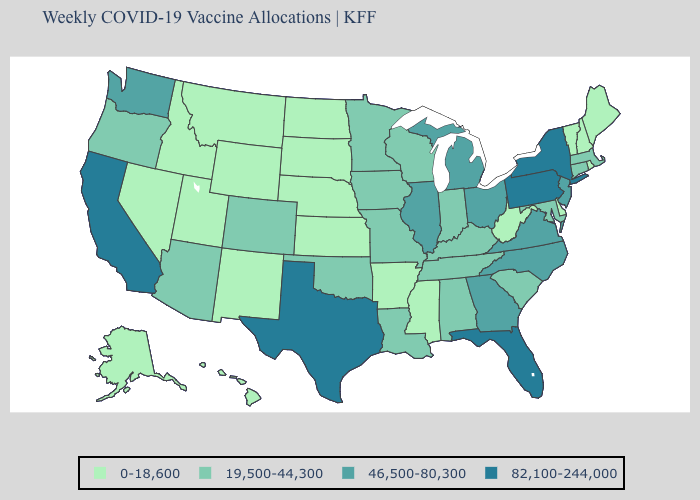Does the first symbol in the legend represent the smallest category?
Quick response, please. Yes. Name the states that have a value in the range 82,100-244,000?
Keep it brief. California, Florida, New York, Pennsylvania, Texas. Name the states that have a value in the range 0-18,600?
Concise answer only. Alaska, Arkansas, Delaware, Hawaii, Idaho, Kansas, Maine, Mississippi, Montana, Nebraska, Nevada, New Hampshire, New Mexico, North Dakota, Rhode Island, South Dakota, Utah, Vermont, West Virginia, Wyoming. Name the states that have a value in the range 82,100-244,000?
Be succinct. California, Florida, New York, Pennsylvania, Texas. What is the lowest value in the MidWest?
Be succinct. 0-18,600. Among the states that border Idaho , does Washington have the lowest value?
Quick response, please. No. How many symbols are there in the legend?
Give a very brief answer. 4. Name the states that have a value in the range 82,100-244,000?
Be succinct. California, Florida, New York, Pennsylvania, Texas. Which states have the lowest value in the West?
Be succinct. Alaska, Hawaii, Idaho, Montana, Nevada, New Mexico, Utah, Wyoming. What is the highest value in the USA?
Be succinct. 82,100-244,000. Among the states that border Delaware , which have the lowest value?
Be succinct. Maryland. Name the states that have a value in the range 0-18,600?
Short answer required. Alaska, Arkansas, Delaware, Hawaii, Idaho, Kansas, Maine, Mississippi, Montana, Nebraska, Nevada, New Hampshire, New Mexico, North Dakota, Rhode Island, South Dakota, Utah, Vermont, West Virginia, Wyoming. Among the states that border Mississippi , does Tennessee have the lowest value?
Concise answer only. No. Which states have the lowest value in the Northeast?
Give a very brief answer. Maine, New Hampshire, Rhode Island, Vermont. 